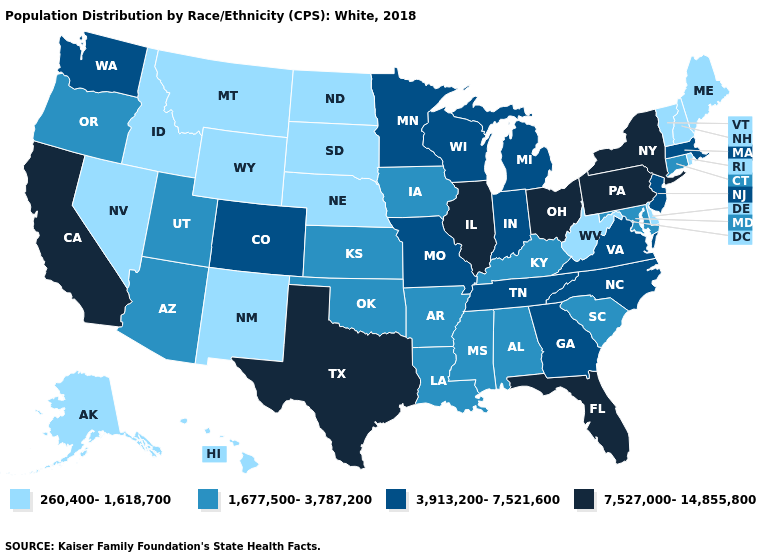Does the map have missing data?
Write a very short answer. No. Name the states that have a value in the range 1,677,500-3,787,200?
Write a very short answer. Alabama, Arizona, Arkansas, Connecticut, Iowa, Kansas, Kentucky, Louisiana, Maryland, Mississippi, Oklahoma, Oregon, South Carolina, Utah. What is the lowest value in the USA?
Write a very short answer. 260,400-1,618,700. Does Vermont have the lowest value in the Northeast?
Short answer required. Yes. Does Vermont have the highest value in the USA?
Write a very short answer. No. Which states hav the highest value in the Northeast?
Be succinct. New York, Pennsylvania. Among the states that border Georgia , which have the highest value?
Be succinct. Florida. What is the value of Wisconsin?
Short answer required. 3,913,200-7,521,600. Is the legend a continuous bar?
Short answer required. No. What is the value of Massachusetts?
Keep it brief. 3,913,200-7,521,600. What is the value of Massachusetts?
Quick response, please. 3,913,200-7,521,600. Name the states that have a value in the range 3,913,200-7,521,600?
Quick response, please. Colorado, Georgia, Indiana, Massachusetts, Michigan, Minnesota, Missouri, New Jersey, North Carolina, Tennessee, Virginia, Washington, Wisconsin. Name the states that have a value in the range 1,677,500-3,787,200?
Short answer required. Alabama, Arizona, Arkansas, Connecticut, Iowa, Kansas, Kentucky, Louisiana, Maryland, Mississippi, Oklahoma, Oregon, South Carolina, Utah. Which states have the highest value in the USA?
Be succinct. California, Florida, Illinois, New York, Ohio, Pennsylvania, Texas. Does the first symbol in the legend represent the smallest category?
Give a very brief answer. Yes. 